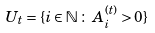<formula> <loc_0><loc_0><loc_500><loc_500>U _ { t } = \{ i \in \mathbb { N } \, \colon \, A ^ { ( t ) } _ { i } > 0 \}</formula> 